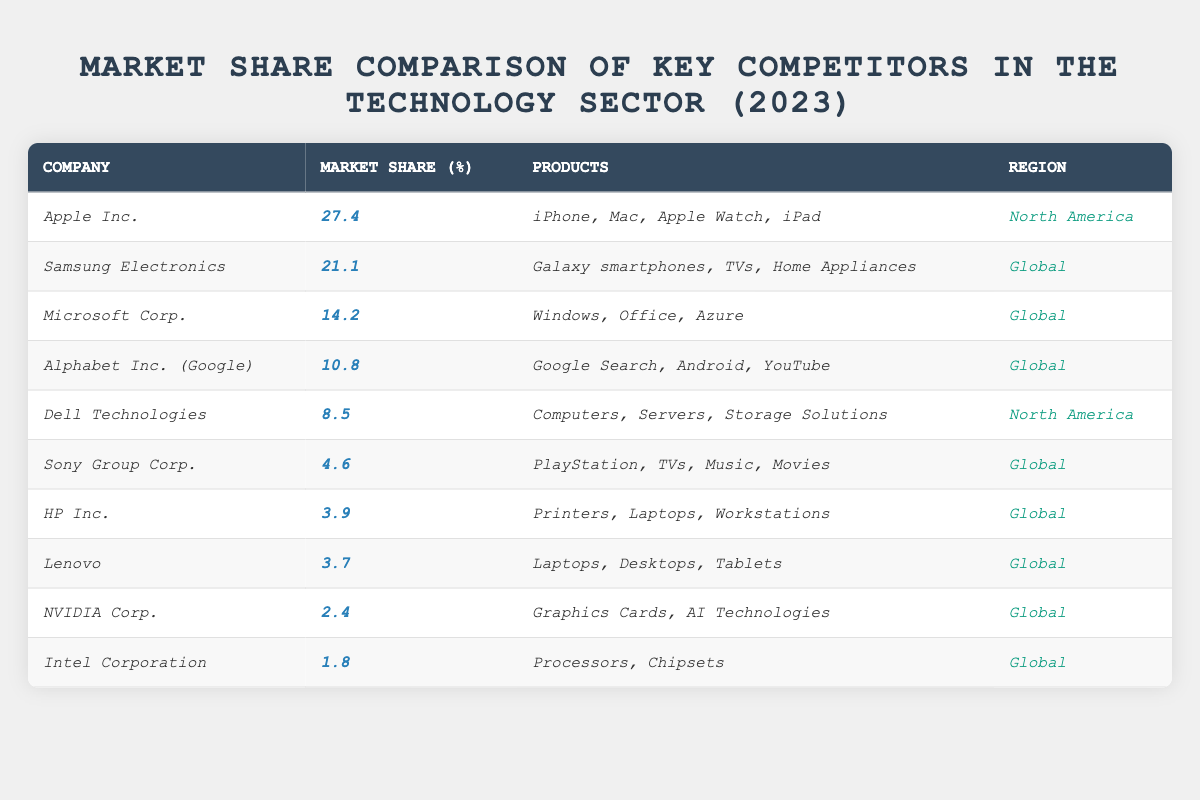What company has the highest market share? From the table, Apple Inc. has the highest market share percentage at 27.4%.
Answer: Apple Inc Which region is Dell Technologies primarily associated with? According to the table, Dell Technologies operates primarily in North America.
Answer: North America What is the combined market share of HP Inc. and Lenovo? To find the combined market share, add the market shares: HP Inc. (3.9%) + Lenovo (3.7%) = 7.6%.
Answer: 7.6% Is Sony Group Corp. more market share than NVIDIA Corp.? Sony Group Corp. has 4.6% market share while NVIDIA Corp. has 2.4%. Since 4.6% is greater than 2.4%, the statement is true.
Answer: Yes What percentage of the market share do the top three companies hold collectively? The top three companies are Apple Inc. (27.4%), Samsung Electronics (21.1%), and Microsoft Corp. (14.2%). Adding these gives: 27.4% + 21.1% + 14.2% = 62.7%.
Answer: 62.7% Which company has the lowest market share, and what is that percentage? From the table, Intel Corporation has the lowest market share at 1.8%.
Answer: Intel Corporation, 1.8% Are there more companies listed under North America or Global regions? There are 2 companies listed under North America (Apple Inc., Dell Technologies) and 8 companies under Global. Since 8 is greater than 2, the statement is true.
Answer: Global If we were to arrange all companies by market share, what position does Alphabet Inc. occupy? Alphabet Inc. has a market share of 10.8%, which makes it the 4th company when listed in descending order of market share.
Answer: 4th What percentage of the market share do companies from North America hold collectively? The companies from North America are Apple Inc. (27.4%) and Dell Technologies (8.5%). Adding these gives: 27.4% + 8.5% = 35.9%.
Answer: 35.9% What is the difference in market share between Samsung Electronics and Microsoft Corp.? Samsung Electronics has 21.1% and Microsoft Corp. has 14.2%. The difference is 21.1% - 14.2% = 6.9%.
Answer: 6.9% 